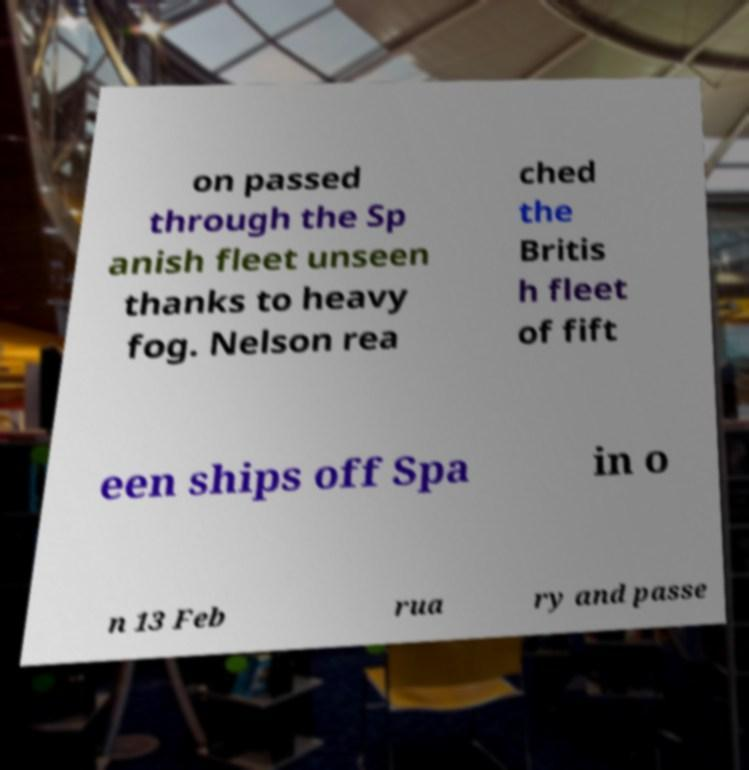Could you extract and type out the text from this image? on passed through the Sp anish fleet unseen thanks to heavy fog. Nelson rea ched the Britis h fleet of fift een ships off Spa in o n 13 Feb rua ry and passe 